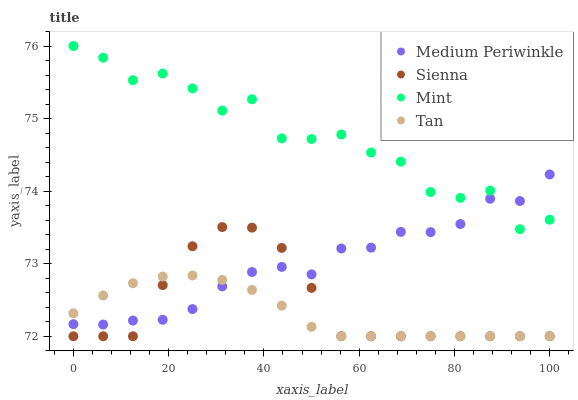Does Tan have the minimum area under the curve?
Answer yes or no. Yes. Does Mint have the maximum area under the curve?
Answer yes or no. Yes. Does Mint have the minimum area under the curve?
Answer yes or no. No. Does Tan have the maximum area under the curve?
Answer yes or no. No. Is Tan the smoothest?
Answer yes or no. Yes. Is Mint the roughest?
Answer yes or no. Yes. Is Mint the smoothest?
Answer yes or no. No. Is Tan the roughest?
Answer yes or no. No. Does Sienna have the lowest value?
Answer yes or no. Yes. Does Mint have the lowest value?
Answer yes or no. No. Does Mint have the highest value?
Answer yes or no. Yes. Does Tan have the highest value?
Answer yes or no. No. Is Sienna less than Mint?
Answer yes or no. Yes. Is Mint greater than Sienna?
Answer yes or no. Yes. Does Medium Periwinkle intersect Tan?
Answer yes or no. Yes. Is Medium Periwinkle less than Tan?
Answer yes or no. No. Is Medium Periwinkle greater than Tan?
Answer yes or no. No. Does Sienna intersect Mint?
Answer yes or no. No. 